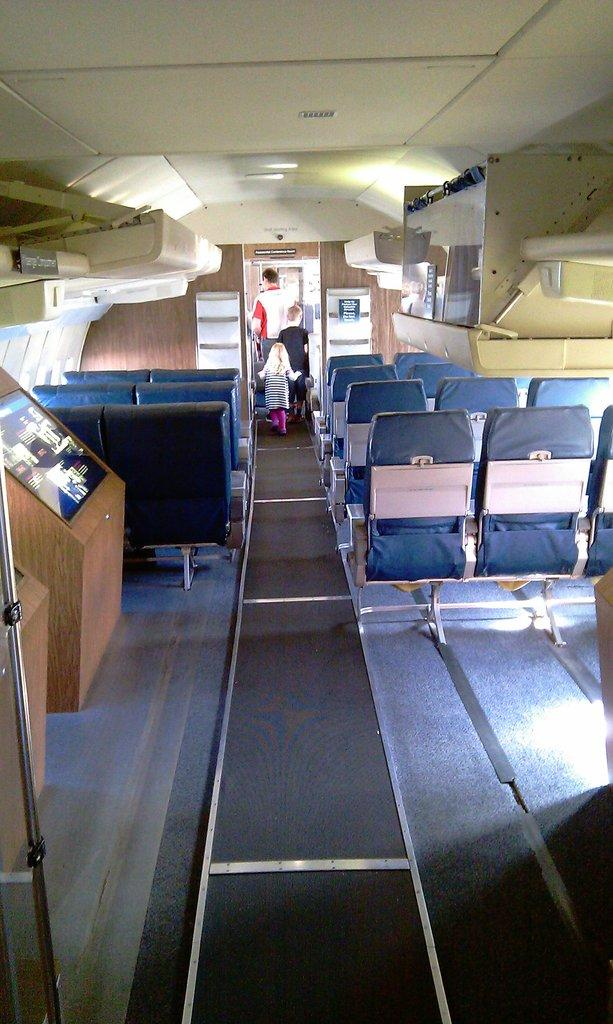What type of furniture is present in the image? There are chairs in the image. What can be seen on the screen in the image? The facts do not specify what is on the screen, so we cannot answer that question definitively. What are the people in the image doing? The people in the image are walking. Can you tell me how many fangs are visible on the people walking in the image? There are no fangs visible on the people walking in the image. What type of vacation are the people in the image planning? There is no information about a vacation in the image or the facts provided. 